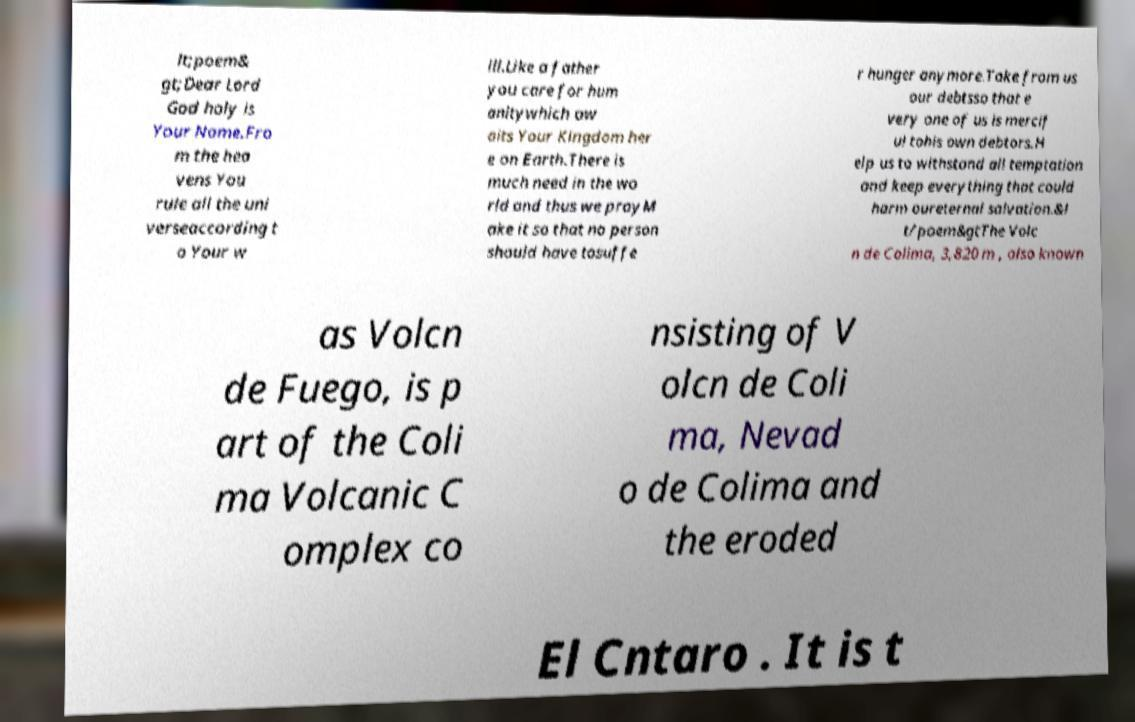Can you accurately transcribe the text from the provided image for me? lt;poem& gt;Dear Lord God holy is Your Name.Fro m the hea vens You rule all the uni verseaccording t o Your w ill.Like a father you care for hum anitywhich aw aits Your Kingdom her e on Earth.There is much need in the wo rld and thus we prayM ake it so that no person should have tosuffe r hunger anymore.Take from us our debtsso that e very one of us is mercif ul tohis own debtors.H elp us to withstand all temptation and keep everything that could harm oureternal salvation.&l t/poem&gtThe Volc n de Colima, 3,820 m , also known as Volcn de Fuego, is p art of the Coli ma Volcanic C omplex co nsisting of V olcn de Coli ma, Nevad o de Colima and the eroded El Cntaro . It is t 